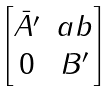Convert formula to latex. <formula><loc_0><loc_0><loc_500><loc_500>\begin{bmatrix} \bar { A ^ { \prime } } & a b \\ 0 & B ^ { \prime } \end{bmatrix}</formula> 